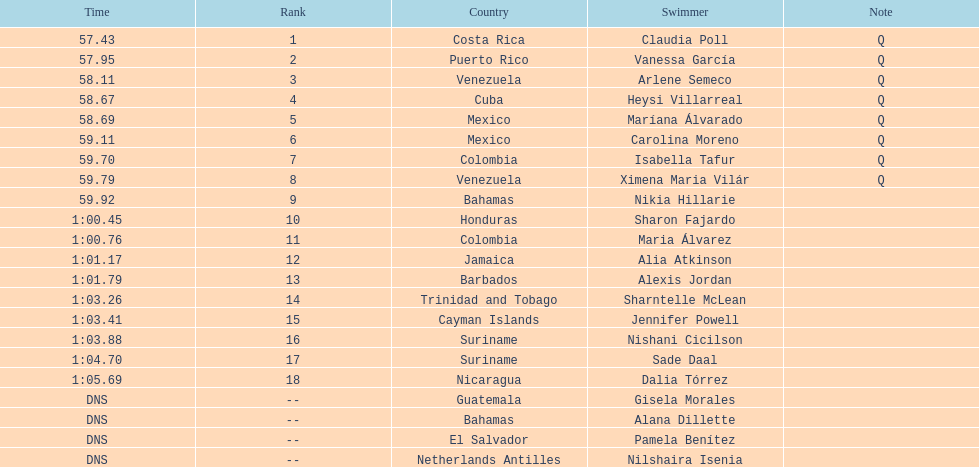Who was the last competitor to actually finish the preliminaries? Dalia Tórrez. 